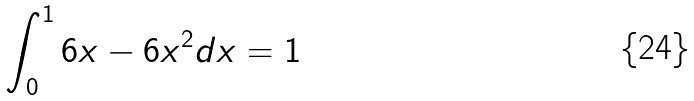Convert formula to latex. <formula><loc_0><loc_0><loc_500><loc_500>\int _ { 0 } ^ { 1 } 6 x - 6 x ^ { 2 } d x = 1</formula> 